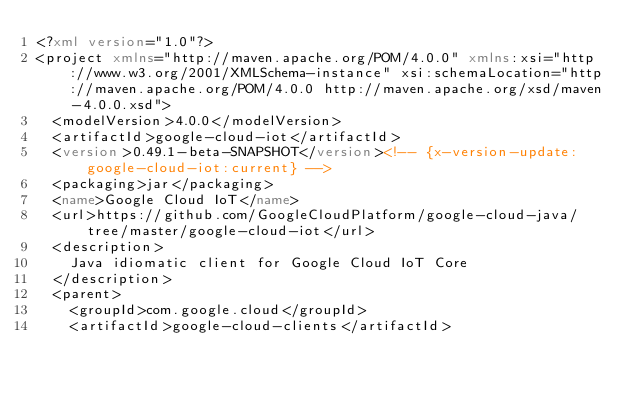<code> <loc_0><loc_0><loc_500><loc_500><_XML_><?xml version="1.0"?>
<project xmlns="http://maven.apache.org/POM/4.0.0" xmlns:xsi="http://www.w3.org/2001/XMLSchema-instance" xsi:schemaLocation="http://maven.apache.org/POM/4.0.0 http://maven.apache.org/xsd/maven-4.0.0.xsd">
  <modelVersion>4.0.0</modelVersion>
  <artifactId>google-cloud-iot</artifactId>
  <version>0.49.1-beta-SNAPSHOT</version><!-- {x-version-update:google-cloud-iot:current} -->
  <packaging>jar</packaging>
  <name>Google Cloud IoT</name>
  <url>https://github.com/GoogleCloudPlatform/google-cloud-java/tree/master/google-cloud-iot</url>
  <description>
    Java idiomatic client for Google Cloud IoT Core
  </description>
  <parent>
    <groupId>com.google.cloud</groupId>
    <artifactId>google-cloud-clients</artifactId></code> 